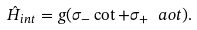Convert formula to latex. <formula><loc_0><loc_0><loc_500><loc_500>\hat { H } _ { i n t } = g ( \sigma _ { - } \cot + \sigma _ { + } \ a o t ) .</formula> 